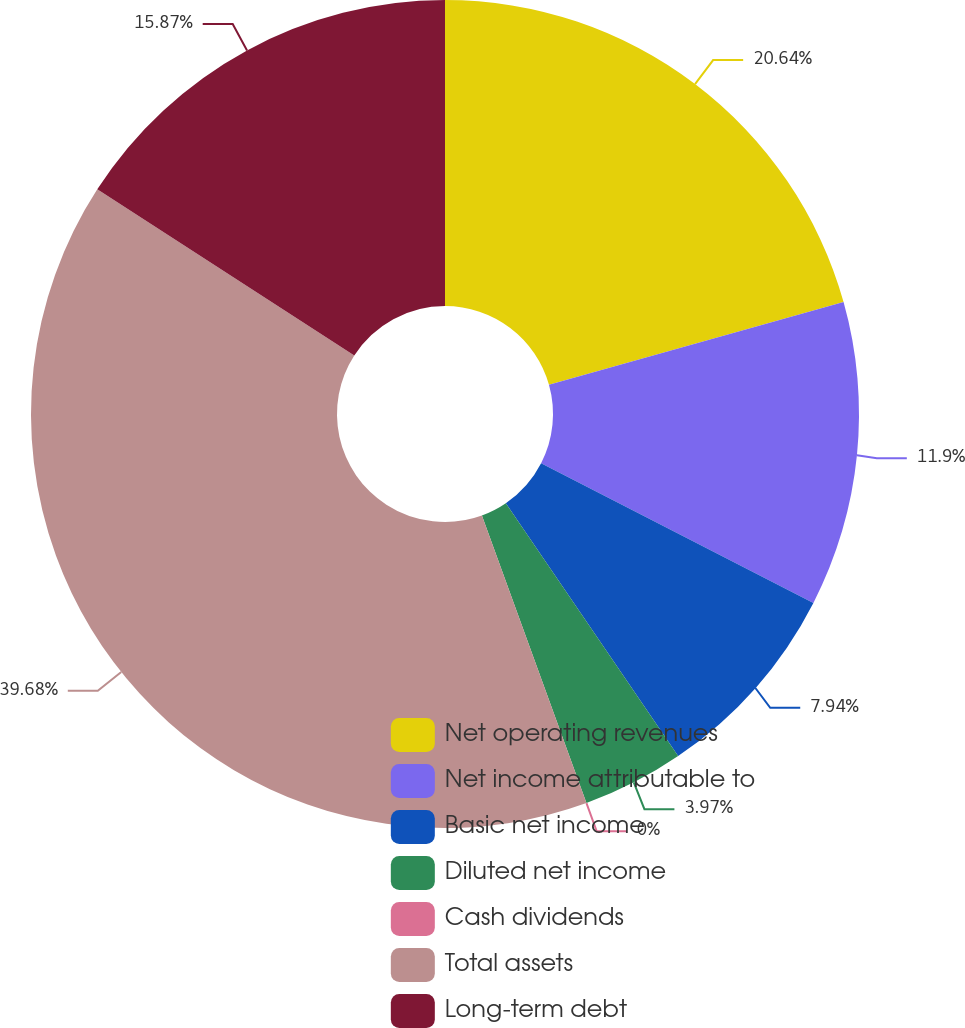Convert chart. <chart><loc_0><loc_0><loc_500><loc_500><pie_chart><fcel>Net operating revenues<fcel>Net income attributable to<fcel>Basic net income<fcel>Diluted net income<fcel>Cash dividends<fcel>Total assets<fcel>Long-term debt<nl><fcel>20.64%<fcel>11.9%<fcel>7.94%<fcel>3.97%<fcel>0.0%<fcel>39.68%<fcel>15.87%<nl></chart> 